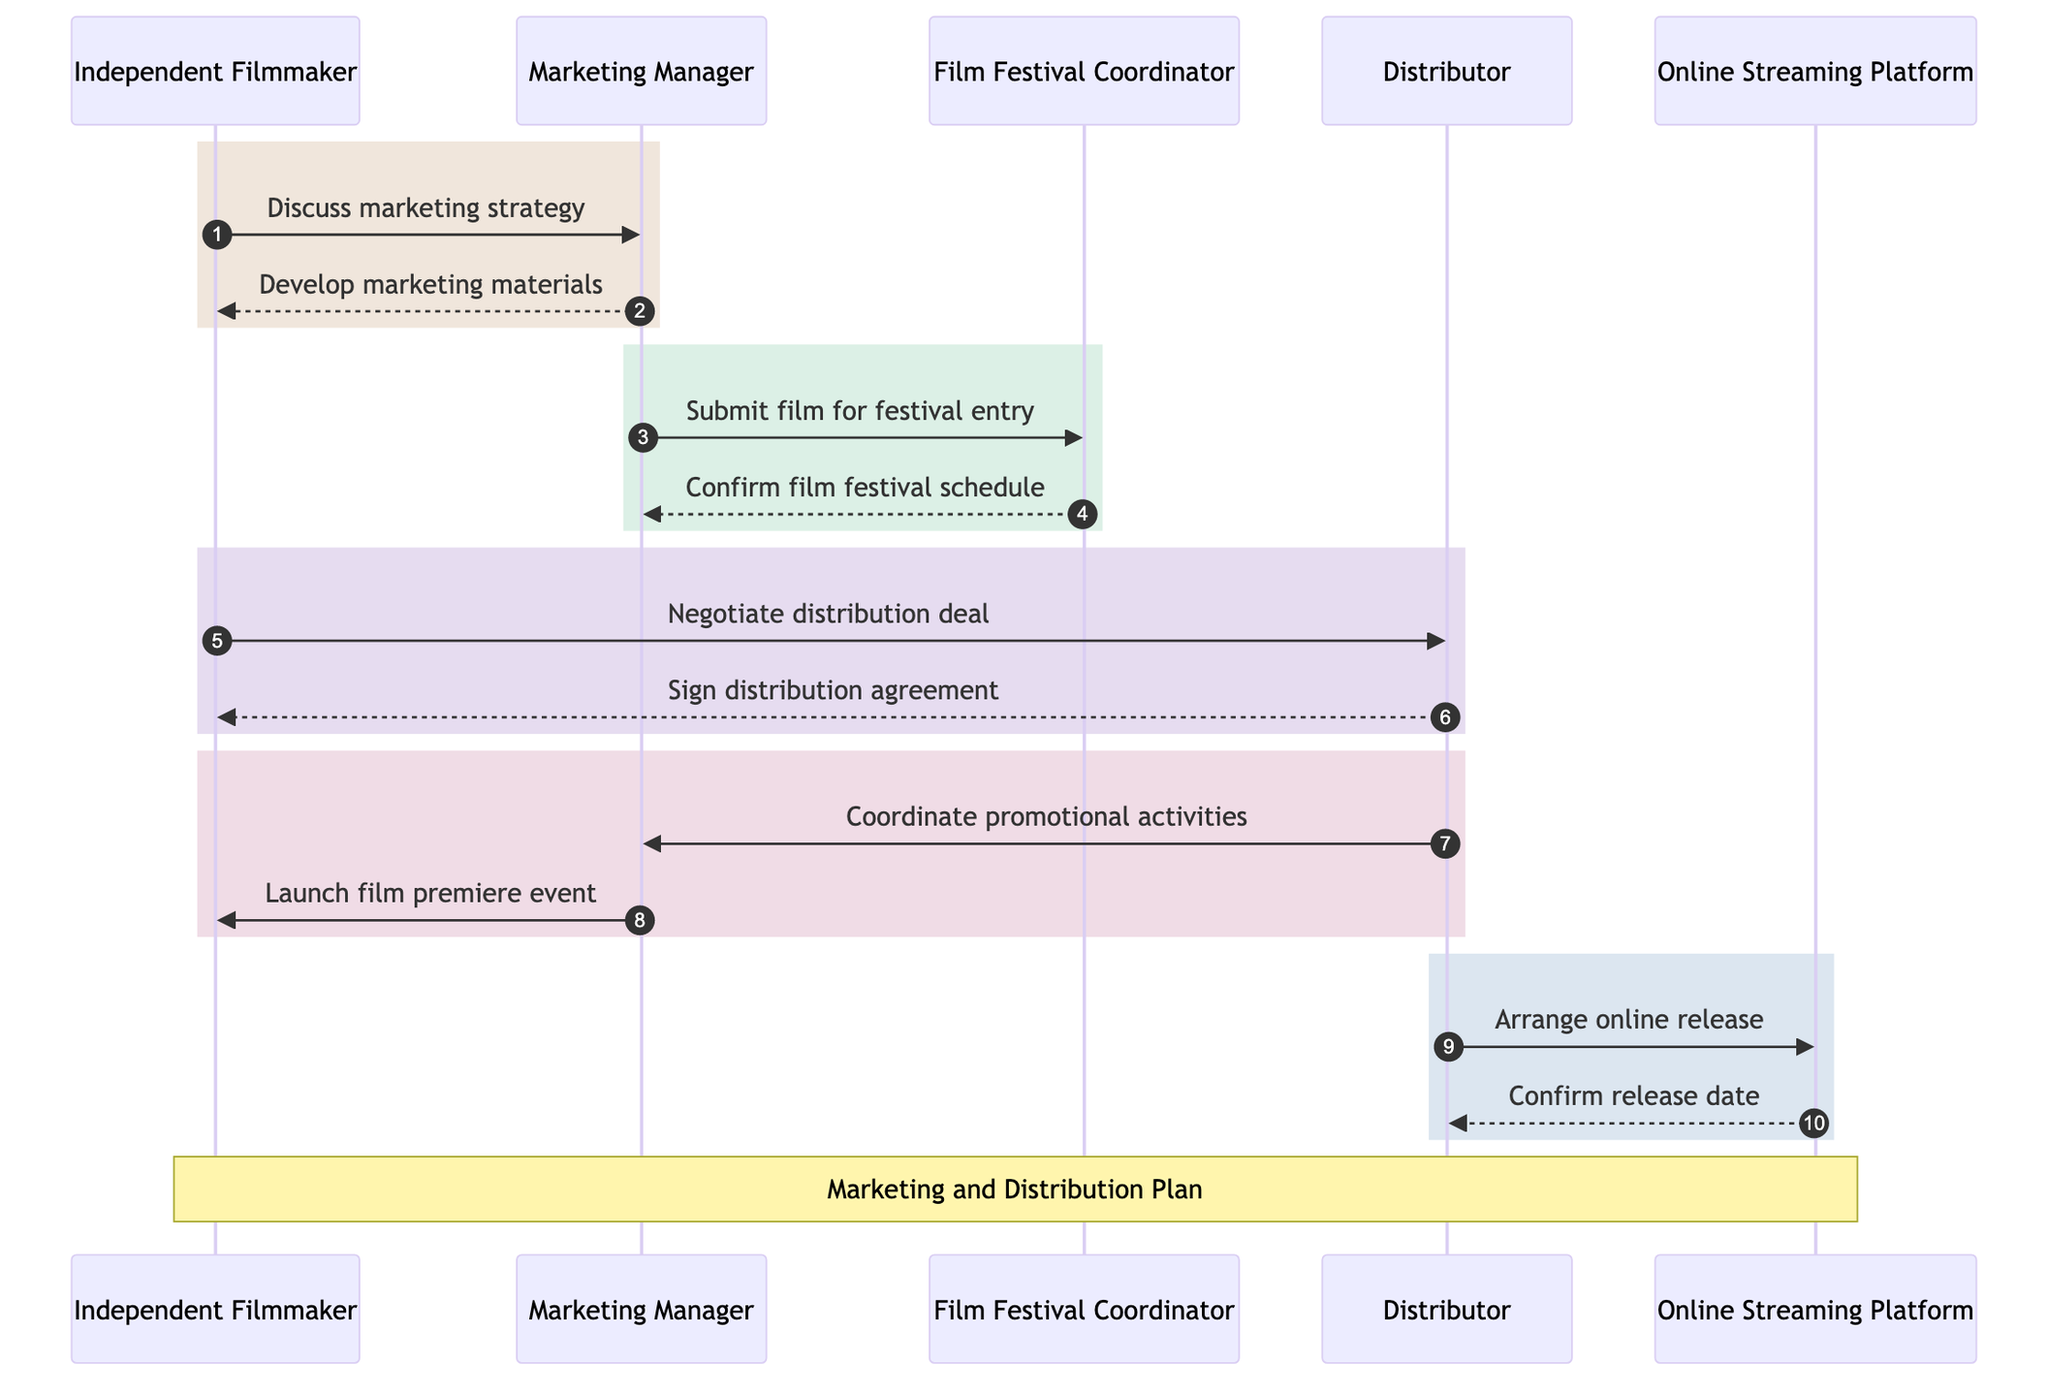What's the first interaction in the diagram? The first interaction in the sequence diagram is between the Independent Filmmaker and the Marketing Manager, where the Independent Filmmaker discusses the marketing strategy.
Answer: Discuss marketing strategy How many total participants are in the diagram? The diagram features five participants: Independent Filmmaker, Marketing Manager, Film Festival Coordinator, Distributor, and Online Streaming Platform. Therefore, the total number is five.
Answer: 5 Which actor confirms the film festival schedule? The Film Festival Coordinator is the actor who confirms the film festival schedule as shown in the interaction with the Marketing Manager.
Answer: Film Festival Coordinator What does the Marketing Manager do after developing marketing materials? The Marketing Manager submits the film for festival entry immediately after developing marketing materials. This follows the sequence established in the diagram.
Answer: Submit film for festival entry What is arranged by the Distributor at the end of the diagram? The Distributor arranges the online release for the film at the end of the diagram, as shown in the last sequence interaction.
Answer: Arrange online release Which two actors are involved in negotiating the distribution deal? The Independent Filmmaker and the Distributor are involved in the negotiation of the distribution deal, according to the corresponding interaction in the diagram.
Answer: Independent Filmmaker and Distributor What is the relationship between the Distributor and the Online Streaming Platform? The relationship here is that the Distributor arranges the online release and subsequently confirms the release date with the Online Streaming Platform. Thus, they collaborate on the film's availability on streaming.
Answer: Arranges online release How many messages are exchanged between the Marketing Manager and the Independent Filmmaker? There are two messages exchanged between them: discussing the marketing strategy and launching the film premiere event. Therefore, the total number of exchanged messages is two.
Answer: 2 